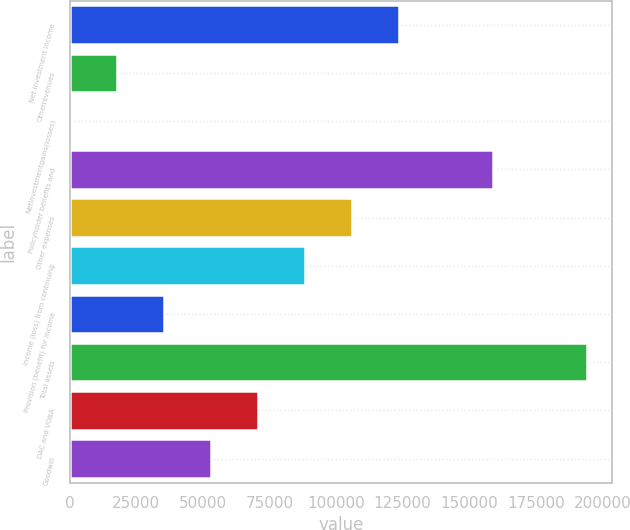<chart> <loc_0><loc_0><loc_500><loc_500><bar_chart><fcel>Net investment income<fcel>Otherrevenues<fcel>Netinvestmentgains(losses)<fcel>Policyholder benefits and<fcel>Other expenses<fcel>Income (loss) from continuing<fcel>Provision (benefit) for income<fcel>Total assets<fcel>DAC and VOBA<fcel>Goodwill<nl><fcel>123484<fcel>17649.1<fcel>10<fcel>158762<fcel>105845<fcel>88205.5<fcel>35288.2<fcel>194040<fcel>70566.4<fcel>52927.3<nl></chart> 